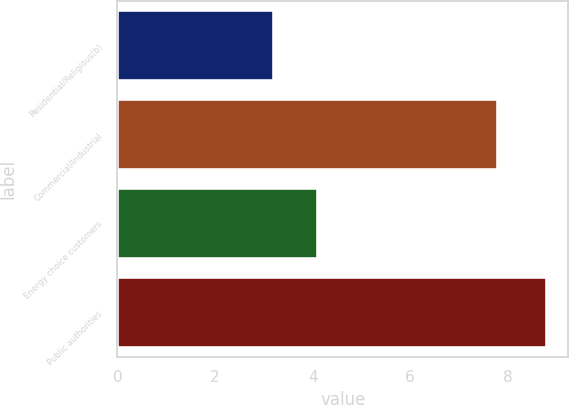Convert chart. <chart><loc_0><loc_0><loc_500><loc_500><bar_chart><fcel>Residential/Religious(b)<fcel>Commercial/Industrial<fcel>Energy choice customers<fcel>Public authorities<nl><fcel>3.2<fcel>7.8<fcel>4.1<fcel>8.8<nl></chart> 